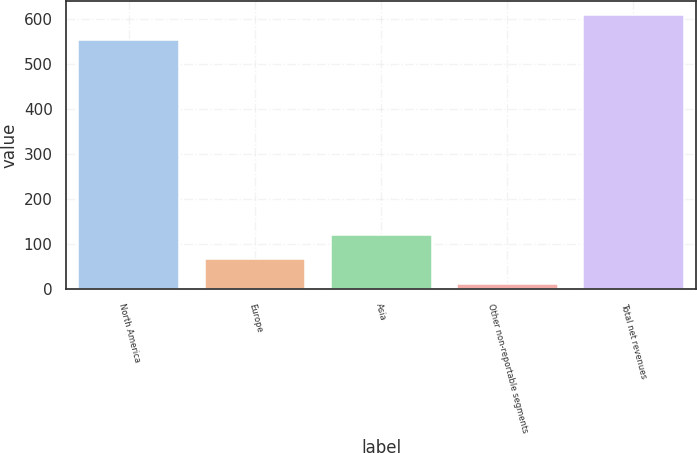Convert chart to OTSL. <chart><loc_0><loc_0><loc_500><loc_500><bar_chart><fcel>North America<fcel>Europe<fcel>Asia<fcel>Other non-reportable segments<fcel>Total net revenues<nl><fcel>555<fcel>66.23<fcel>120.76<fcel>11.7<fcel>609.53<nl></chart> 